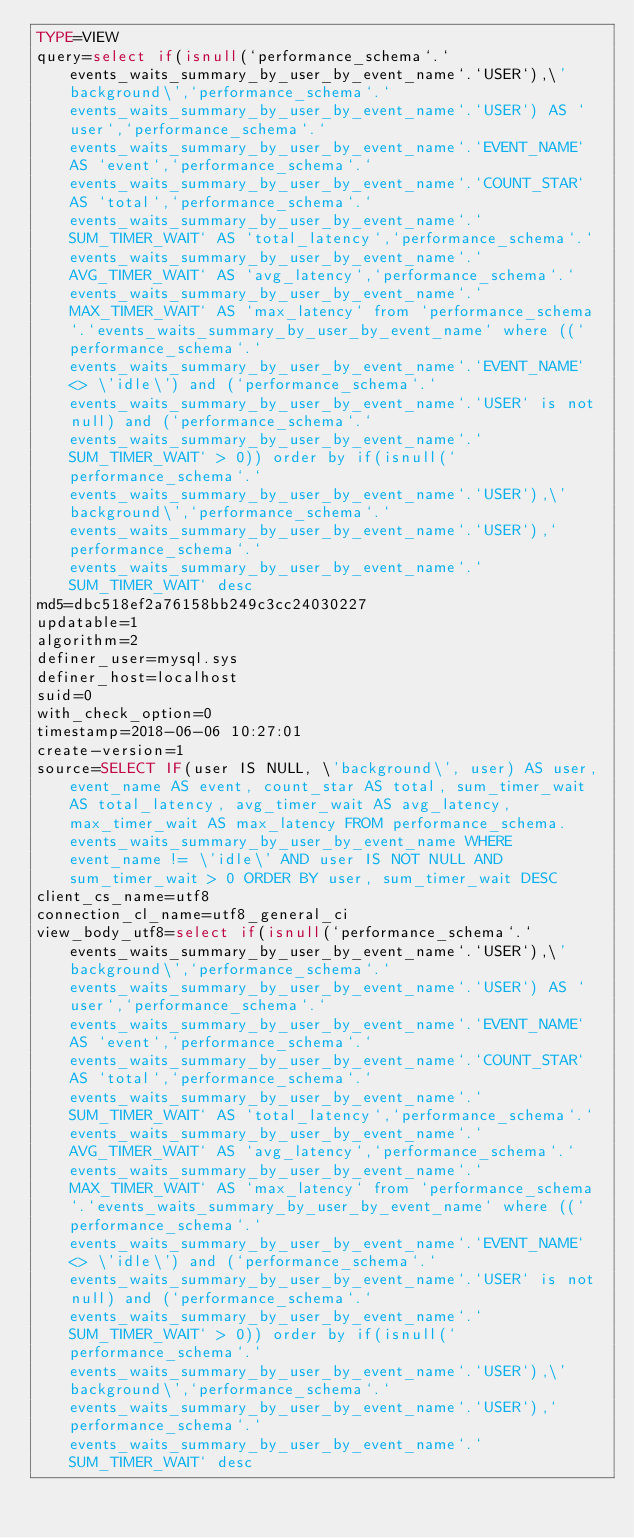Convert code to text. <code><loc_0><loc_0><loc_500><loc_500><_VisualBasic_>TYPE=VIEW
query=select if(isnull(`performance_schema`.`events_waits_summary_by_user_by_event_name`.`USER`),\'background\',`performance_schema`.`events_waits_summary_by_user_by_event_name`.`USER`) AS `user`,`performance_schema`.`events_waits_summary_by_user_by_event_name`.`EVENT_NAME` AS `event`,`performance_schema`.`events_waits_summary_by_user_by_event_name`.`COUNT_STAR` AS `total`,`performance_schema`.`events_waits_summary_by_user_by_event_name`.`SUM_TIMER_WAIT` AS `total_latency`,`performance_schema`.`events_waits_summary_by_user_by_event_name`.`AVG_TIMER_WAIT` AS `avg_latency`,`performance_schema`.`events_waits_summary_by_user_by_event_name`.`MAX_TIMER_WAIT` AS `max_latency` from `performance_schema`.`events_waits_summary_by_user_by_event_name` where ((`performance_schema`.`events_waits_summary_by_user_by_event_name`.`EVENT_NAME` <> \'idle\') and (`performance_schema`.`events_waits_summary_by_user_by_event_name`.`USER` is not null) and (`performance_schema`.`events_waits_summary_by_user_by_event_name`.`SUM_TIMER_WAIT` > 0)) order by if(isnull(`performance_schema`.`events_waits_summary_by_user_by_event_name`.`USER`),\'background\',`performance_schema`.`events_waits_summary_by_user_by_event_name`.`USER`),`performance_schema`.`events_waits_summary_by_user_by_event_name`.`SUM_TIMER_WAIT` desc
md5=dbc518ef2a76158bb249c3cc24030227
updatable=1
algorithm=2
definer_user=mysql.sys
definer_host=localhost
suid=0
with_check_option=0
timestamp=2018-06-06 10:27:01
create-version=1
source=SELECT IF(user IS NULL, \'background\', user) AS user, event_name AS event, count_star AS total, sum_timer_wait AS total_latency, avg_timer_wait AS avg_latency, max_timer_wait AS max_latency FROM performance_schema.events_waits_summary_by_user_by_event_name WHERE event_name != \'idle\' AND user IS NOT NULL AND sum_timer_wait > 0 ORDER BY user, sum_timer_wait DESC
client_cs_name=utf8
connection_cl_name=utf8_general_ci
view_body_utf8=select if(isnull(`performance_schema`.`events_waits_summary_by_user_by_event_name`.`USER`),\'background\',`performance_schema`.`events_waits_summary_by_user_by_event_name`.`USER`) AS `user`,`performance_schema`.`events_waits_summary_by_user_by_event_name`.`EVENT_NAME` AS `event`,`performance_schema`.`events_waits_summary_by_user_by_event_name`.`COUNT_STAR` AS `total`,`performance_schema`.`events_waits_summary_by_user_by_event_name`.`SUM_TIMER_WAIT` AS `total_latency`,`performance_schema`.`events_waits_summary_by_user_by_event_name`.`AVG_TIMER_WAIT` AS `avg_latency`,`performance_schema`.`events_waits_summary_by_user_by_event_name`.`MAX_TIMER_WAIT` AS `max_latency` from `performance_schema`.`events_waits_summary_by_user_by_event_name` where ((`performance_schema`.`events_waits_summary_by_user_by_event_name`.`EVENT_NAME` <> \'idle\') and (`performance_schema`.`events_waits_summary_by_user_by_event_name`.`USER` is not null) and (`performance_schema`.`events_waits_summary_by_user_by_event_name`.`SUM_TIMER_WAIT` > 0)) order by if(isnull(`performance_schema`.`events_waits_summary_by_user_by_event_name`.`USER`),\'background\',`performance_schema`.`events_waits_summary_by_user_by_event_name`.`USER`),`performance_schema`.`events_waits_summary_by_user_by_event_name`.`SUM_TIMER_WAIT` desc
</code> 